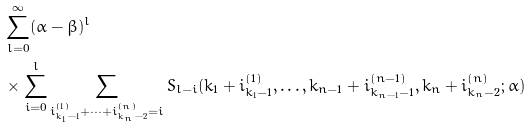Convert formula to latex. <formula><loc_0><loc_0><loc_500><loc_500>& \sum _ { l = 0 } ^ { \infty } ( \alpha - \beta ) ^ { l } \\ & \times \sum _ { i = 0 } ^ { l } \sum _ { i _ { k _ { 1 } - 1 } ^ { ( 1 ) } + \cdots + i _ { k _ { n } - 2 } ^ { ( n ) } = i } S _ { l - i } ( k _ { 1 } + i _ { k _ { 1 } - 1 } ^ { ( 1 ) } , \dots , k _ { n - 1 } + i _ { k _ { n - 1 } - 1 } ^ { ( n - 1 ) } , k _ { n } + i _ { k _ { n } - 2 } ^ { ( n ) } ; \alpha )</formula> 